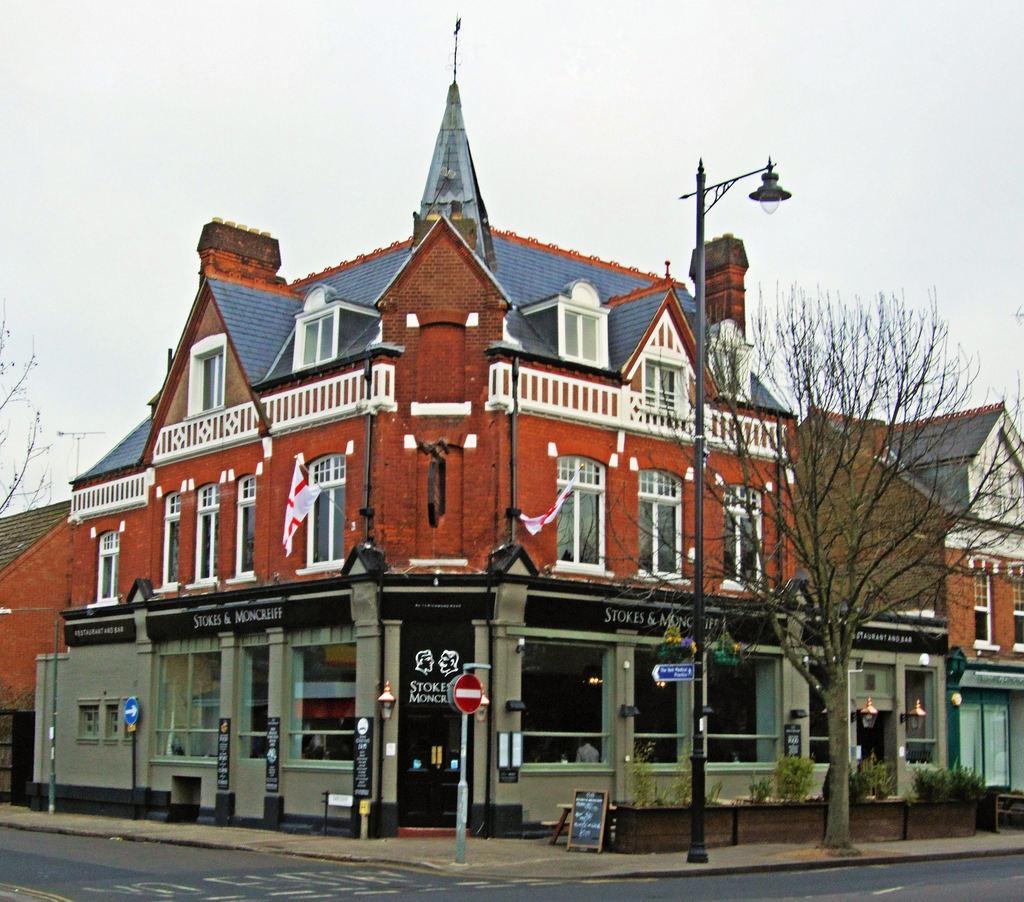How would you summarize this image in a sentence or two? We can see lights and boards on poles and we can see dried tree,board on the surface,plants,road and building. In the background we can see sky. 